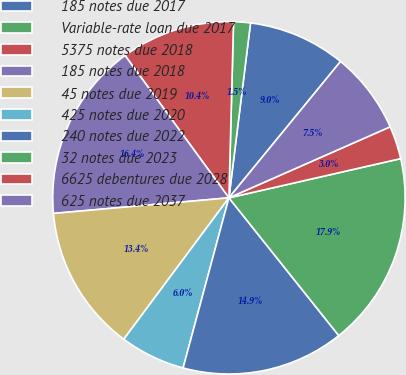<chart> <loc_0><loc_0><loc_500><loc_500><pie_chart><fcel>185 notes due 2017<fcel>Variable-rate loan due 2017<fcel>5375 notes due 2018<fcel>185 notes due 2018<fcel>45 notes due 2019<fcel>425 notes due 2020<fcel>240 notes due 2022<fcel>32 notes due 2023<fcel>6625 debentures due 2028<fcel>625 notes due 2037<nl><fcel>8.96%<fcel>1.54%<fcel>10.45%<fcel>16.38%<fcel>13.41%<fcel>5.99%<fcel>14.9%<fcel>17.86%<fcel>3.03%<fcel>7.48%<nl></chart> 